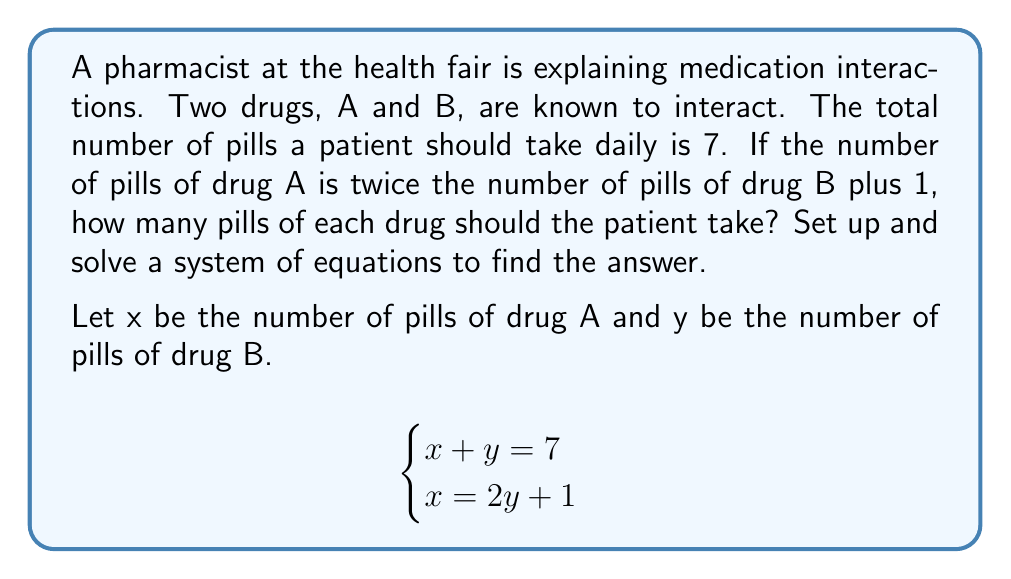Help me with this question. Let's solve this system of equations step by step:

1) We have two equations:
   $$\begin{cases}
   x + y = 7 \quad \text{(Equation 1)} \\
   x = 2y + 1 \quad \text{(Equation 2)}
   \end{cases}$$

2) Substitute Equation 2 into Equation 1:
   $$(2y + 1) + y = 7$$

3) Simplify:
   $$2y + 1 + y = 7$$
   $$3y + 1 = 7$$

4) Subtract 1 from both sides:
   $$3y = 6$$

5) Divide both sides by 3:
   $$y = 2$$

6) Now that we know y, we can substitute this value into Equation 2 to find x:
   $$x = 2y + 1$$
   $$x = 2(2) + 1$$
   $$x = 4 + 1 = 5$$

Therefore, the patient should take 5 pills of drug A and 2 pills of drug B.
Answer: Drug A: 5 pills, Drug B: 2 pills 